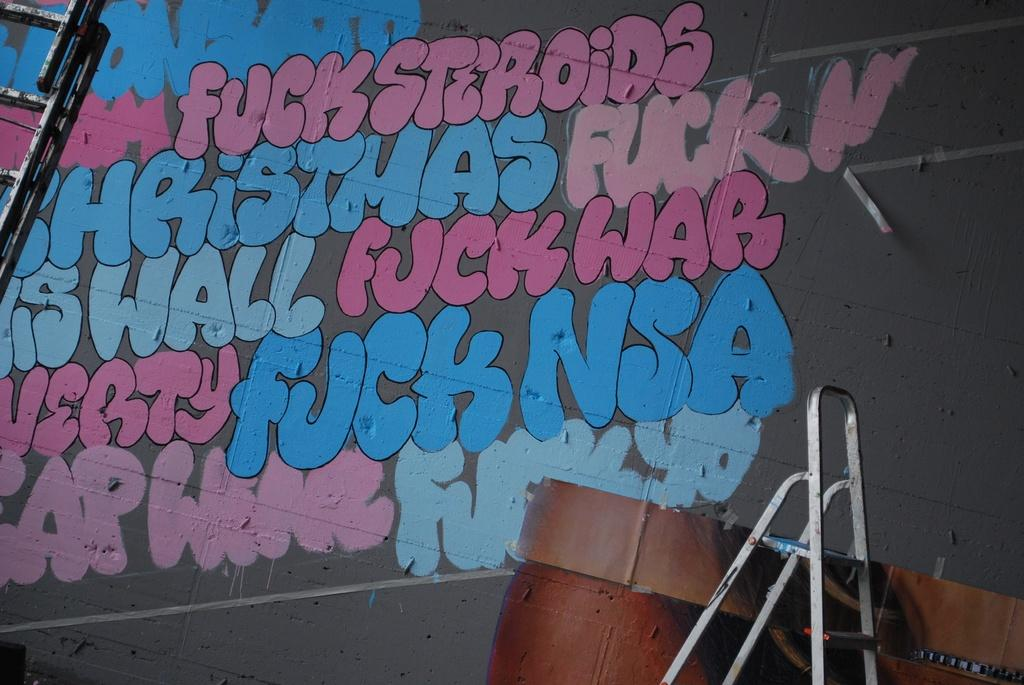What is written or displayed on the wall in the image? There are sentences on the wall in the image. What object can be seen on the right side of the image? There is a ladder on the right side of the image. How many rings are visible on the wall in the image? There are no rings visible on the wall in the image. What type of dress is being worn by the women in the image? There are no women or dresses present in the image. 